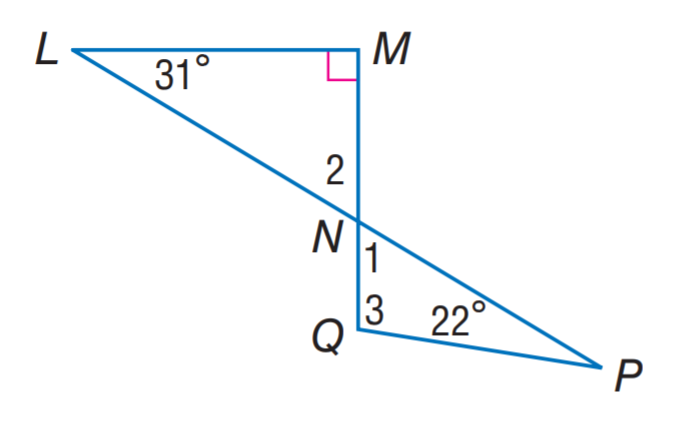Question: Find m \angle 3.
Choices:
A. 59
B. 81
C. 99
D. 102
Answer with the letter. Answer: C Question: Find m \angle 2.
Choices:
A. 31
B. 42
C. 59
D. 63
Answer with the letter. Answer: C Question: Find m \angle 1.
Choices:
A. 31
B. 42
C. 59
D. 63
Answer with the letter. Answer: C 